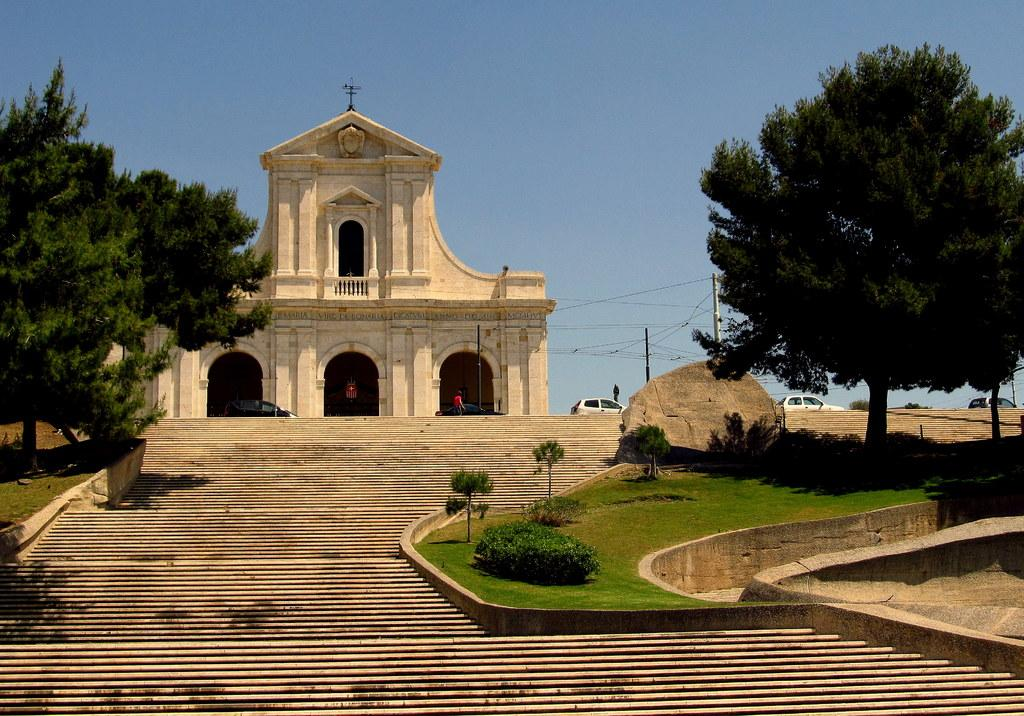What type of structure can be seen in the image? There is a building in the image. Are there any architectural features visible in the image? Yes, there are stairs in the image. What mode of transportation can be seen in the image? Motor vehicles are present in the image. Are there any people visible in the image? Yes, there are persons in the image. What type of vertical structures can be seen in the image? Poles are visible in the image. Are there any electrical components in the image? Yes, electric cables are present in the image. What type of vegetation can be seen in the image? Bushes and plants are visible in the image. What type of natural feature can be seen in the image? There is a rock in the image. What type of large plants can be seen in the image? Trees are visible in the image. What part of the natural environment is visible in the image? The sky is visible in the image. What type of hate can be seen in the image? There is no hate present in the image; it is a scene featuring a building, stairs, motor vehicles, persons, poles, electric cables, bushes, plants, a rock, trees, and the sky. What type of smoke can be seen in the image? There is no smoke present in the image. What type of noise can be heard in the image? The image is a still picture and does not contain any audible noise. 